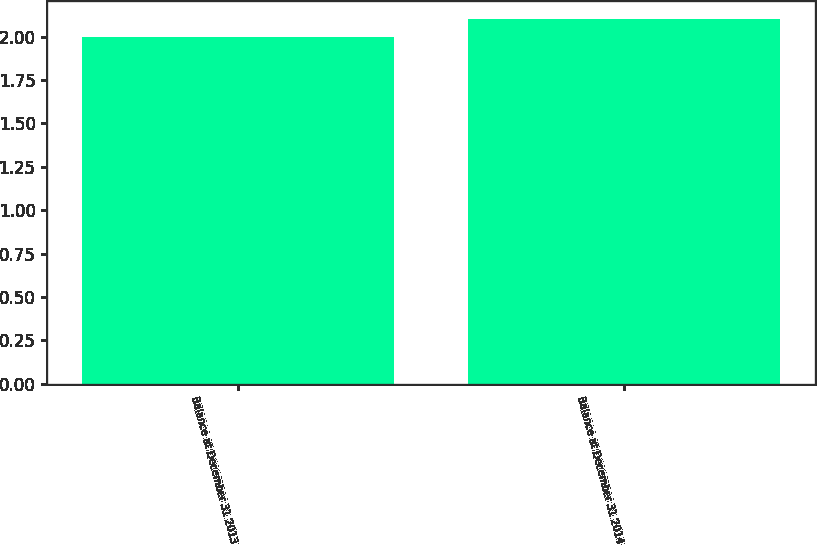Convert chart to OTSL. <chart><loc_0><loc_0><loc_500><loc_500><bar_chart><fcel>Balance at December 31 2013<fcel>Balance at December 31 2014<nl><fcel>2<fcel>2.1<nl></chart> 